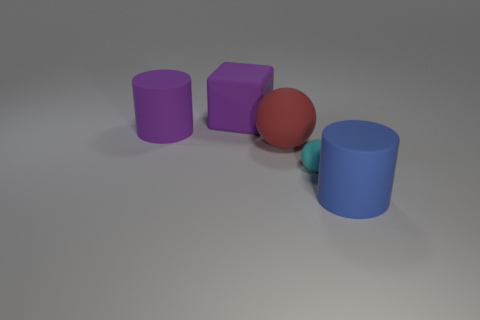Add 1 cyan matte objects. How many objects exist? 6 Subtract all purple cylinders. How many cylinders are left? 1 Subtract 1 spheres. How many spheres are left? 1 Subtract all cyan cubes. Subtract all yellow spheres. How many cubes are left? 1 Add 5 purple matte blocks. How many purple matte blocks are left? 6 Add 5 large cylinders. How many large cylinders exist? 7 Subtract 0 brown blocks. How many objects are left? 5 Subtract all spheres. How many objects are left? 3 Subtract all brown balls. How many yellow cylinders are left? 0 Subtract all big red spheres. Subtract all large blue rubber things. How many objects are left? 3 